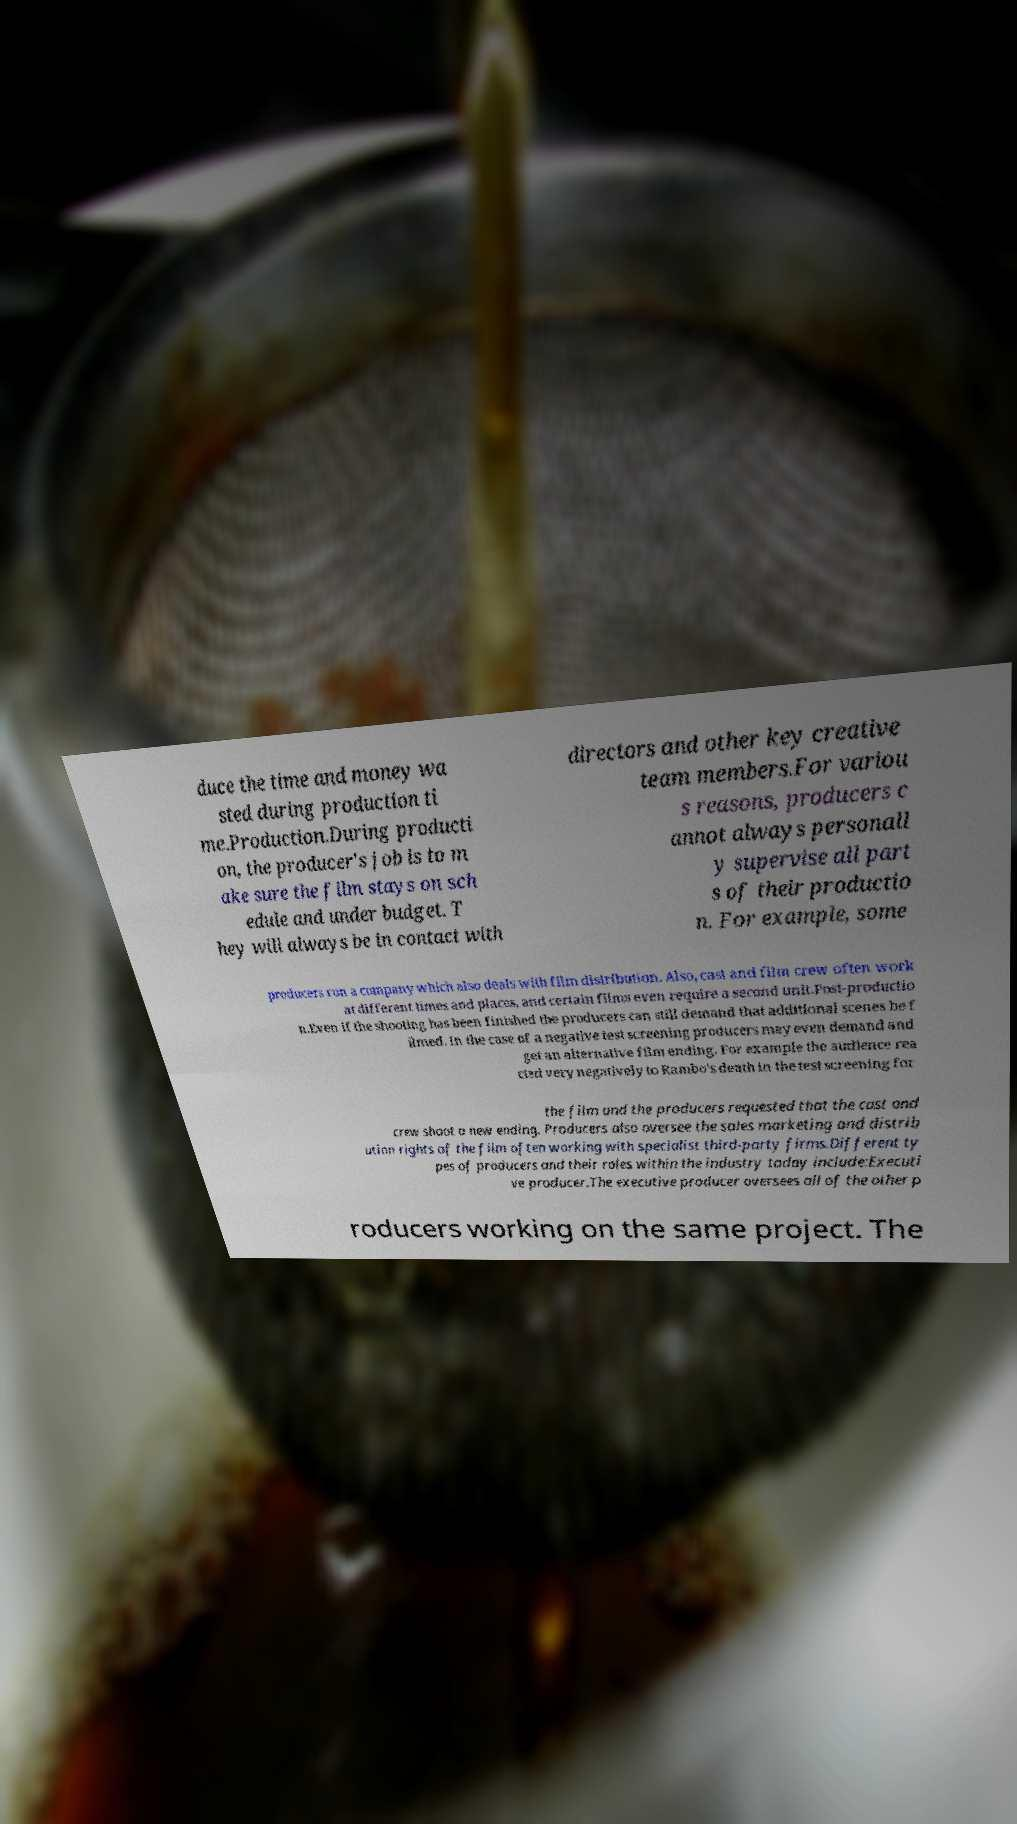Could you assist in decoding the text presented in this image and type it out clearly? duce the time and money wa sted during production ti me.Production.During producti on, the producer's job is to m ake sure the film stays on sch edule and under budget. T hey will always be in contact with directors and other key creative team members.For variou s reasons, producers c annot always personall y supervise all part s of their productio n. For example, some producers run a company which also deals with film distribution. Also, cast and film crew often work at different times and places, and certain films even require a second unit.Post-productio n.Even if the shooting has been finished the producers can still demand that additional scenes be f ilmed. In the case of a negative test screening producers may even demand and get an alternative film ending. For example the audience rea cted very negatively to Rambo's death in the test screening for the film and the producers requested that the cast and crew shoot a new ending. Producers also oversee the sales marketing and distrib ution rights of the film often working with specialist third-party firms.Different ty pes of producers and their roles within the industry today include:Executi ve producer.The executive producer oversees all of the other p roducers working on the same project. The 